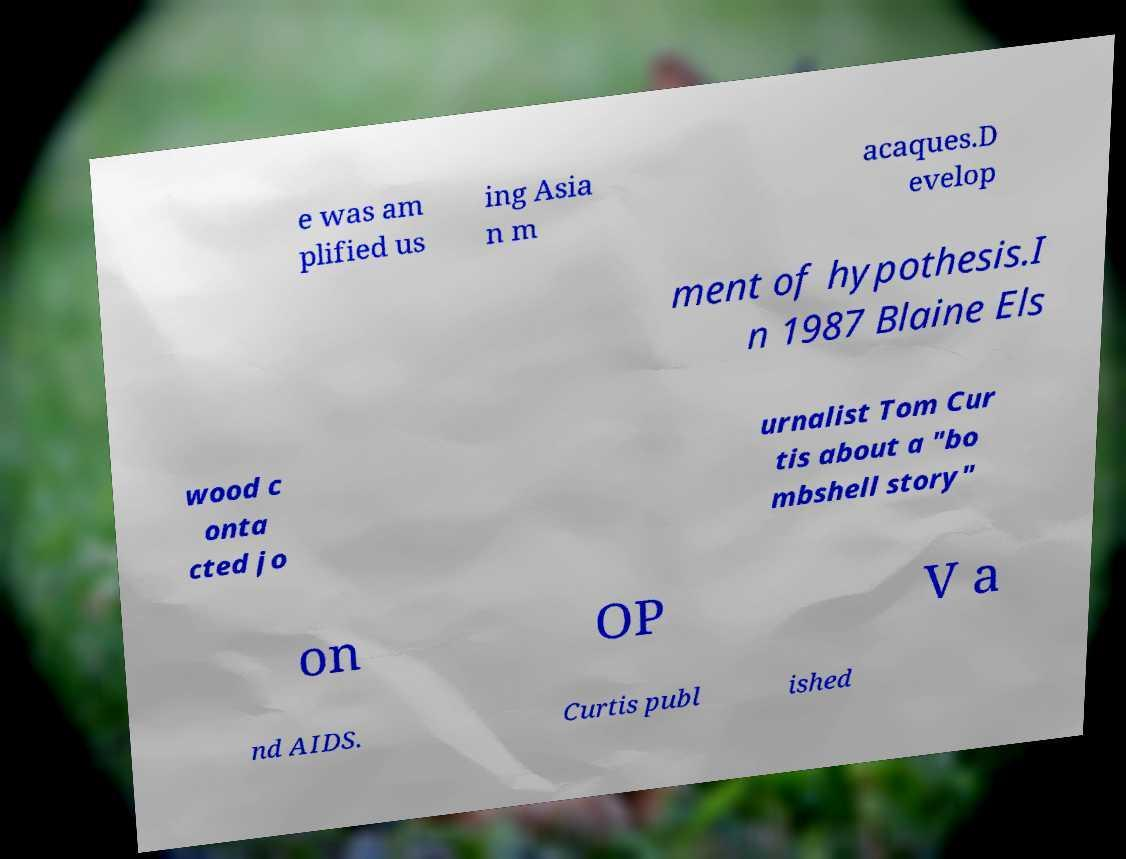What messages or text are displayed in this image? I need them in a readable, typed format. e was am plified us ing Asia n m acaques.D evelop ment of hypothesis.I n 1987 Blaine Els wood c onta cted jo urnalist Tom Cur tis about a "bo mbshell story" on OP V a nd AIDS. Curtis publ ished 